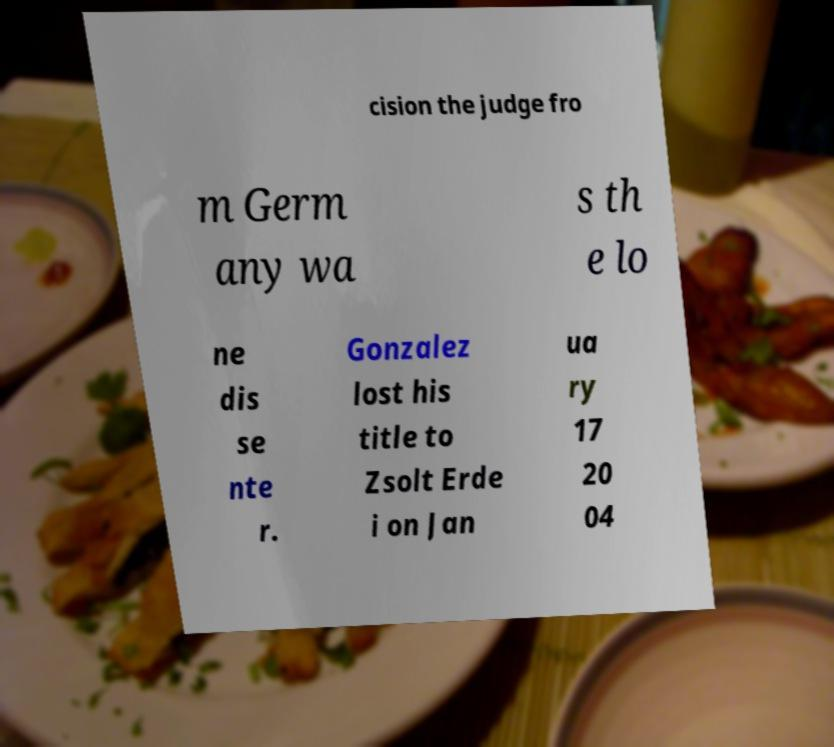For documentation purposes, I need the text within this image transcribed. Could you provide that? cision the judge fro m Germ any wa s th e lo ne dis se nte r. Gonzalez lost his title to Zsolt Erde i on Jan ua ry 17 20 04 